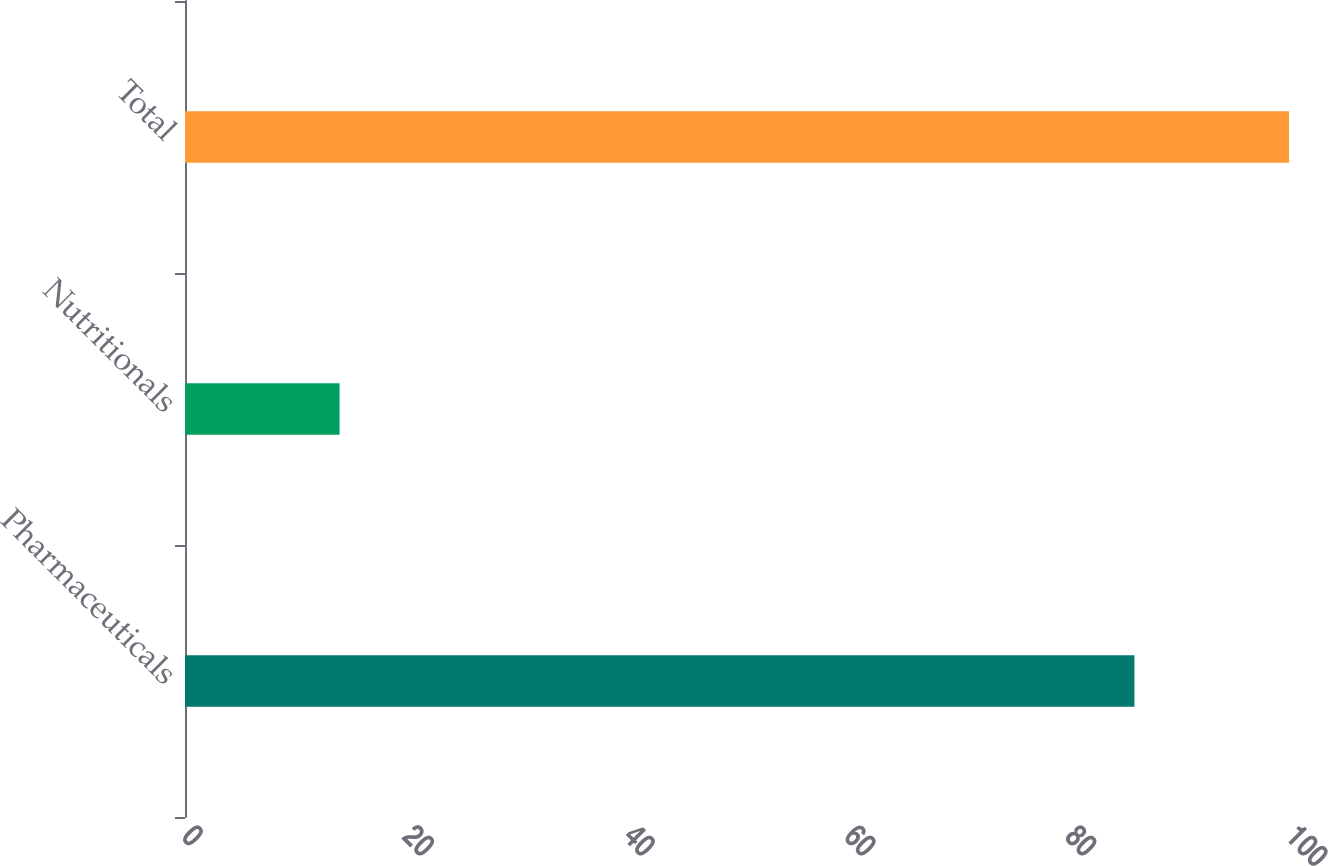Convert chart. <chart><loc_0><loc_0><loc_500><loc_500><bar_chart><fcel>Pharmaceuticals<fcel>Nutritionals<fcel>Total<nl><fcel>86<fcel>14<fcel>100<nl></chart> 